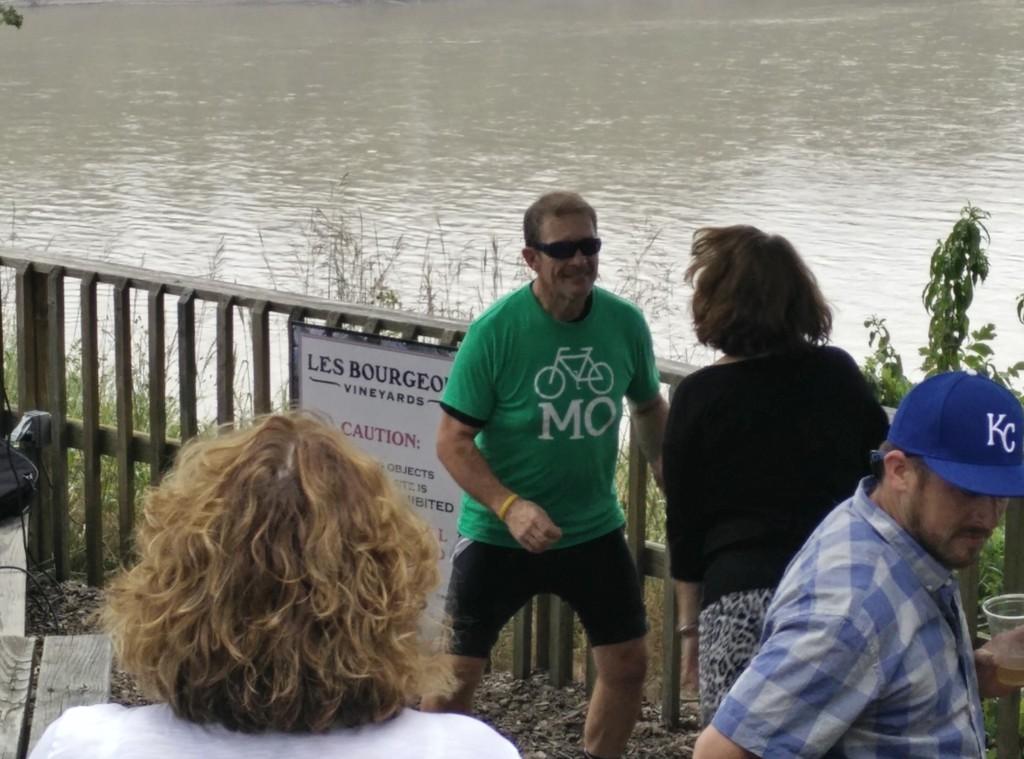Can you describe this image briefly? In this picture I can see few people standing and talking, fencing and water flow. 